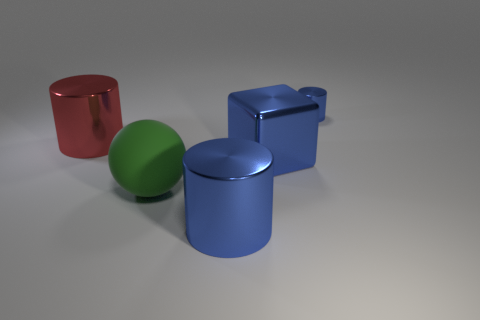Are there any objects that are to the right of the blue shiny cylinder left of the blue shiny cylinder behind the big rubber thing?
Your answer should be very brief. Yes. What number of other objects are there of the same color as the large sphere?
Your response must be concise. 0. There is a blue object that is in front of the block; is its shape the same as the green thing?
Provide a short and direct response. No. What color is the other large metallic object that is the same shape as the large red metal thing?
Provide a succinct answer. Blue. Are there any other things that have the same material as the green sphere?
Give a very brief answer. No. There is another blue metal thing that is the same shape as the small thing; what is its size?
Provide a succinct answer. Large. There is a thing that is behind the big blue metal cube and in front of the small blue metal cylinder; what material is it made of?
Your answer should be compact. Metal. Is the color of the large object that is on the right side of the large blue shiny cylinder the same as the large ball?
Your response must be concise. No. There is a tiny metal thing; does it have the same color as the big shiny cylinder on the right side of the red shiny cylinder?
Your answer should be very brief. Yes. There is a big green ball; are there any objects in front of it?
Provide a succinct answer. Yes. 